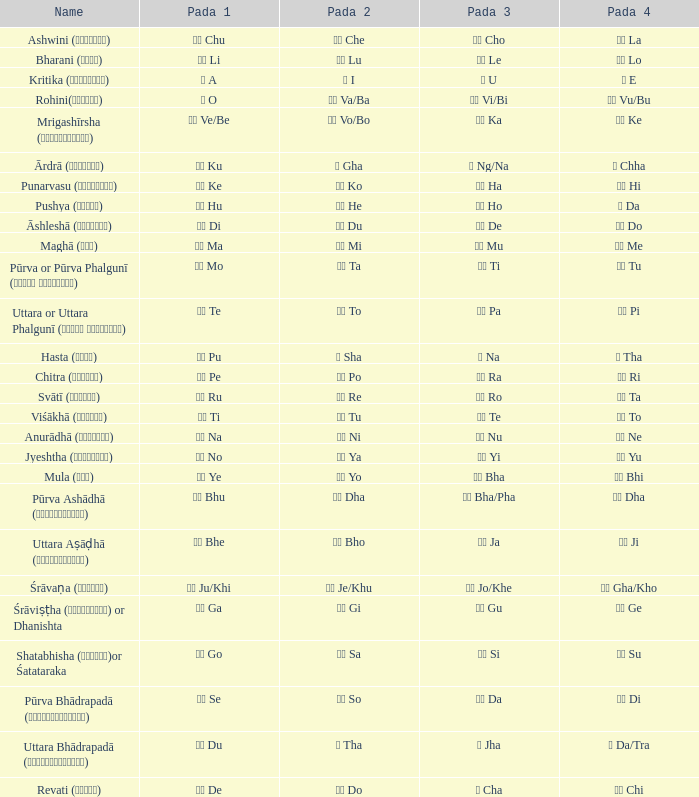What do we call the ङ (ng/na) symbol? Ārdrā (आर्द्रा). 